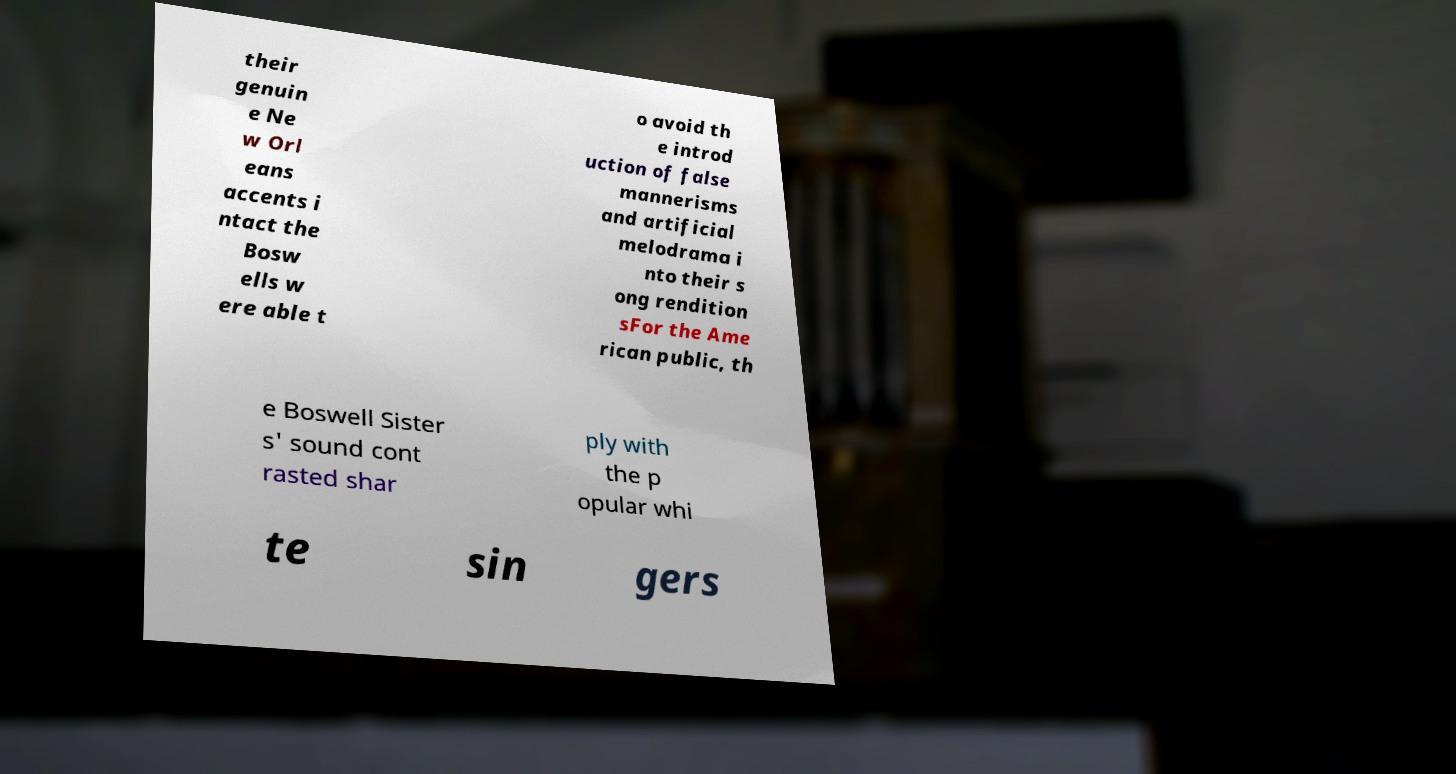What messages or text are displayed in this image? I need them in a readable, typed format. their genuin e Ne w Orl eans accents i ntact the Bosw ells w ere able t o avoid th e introd uction of false mannerisms and artificial melodrama i nto their s ong rendition sFor the Ame rican public, th e Boswell Sister s' sound cont rasted shar ply with the p opular whi te sin gers 